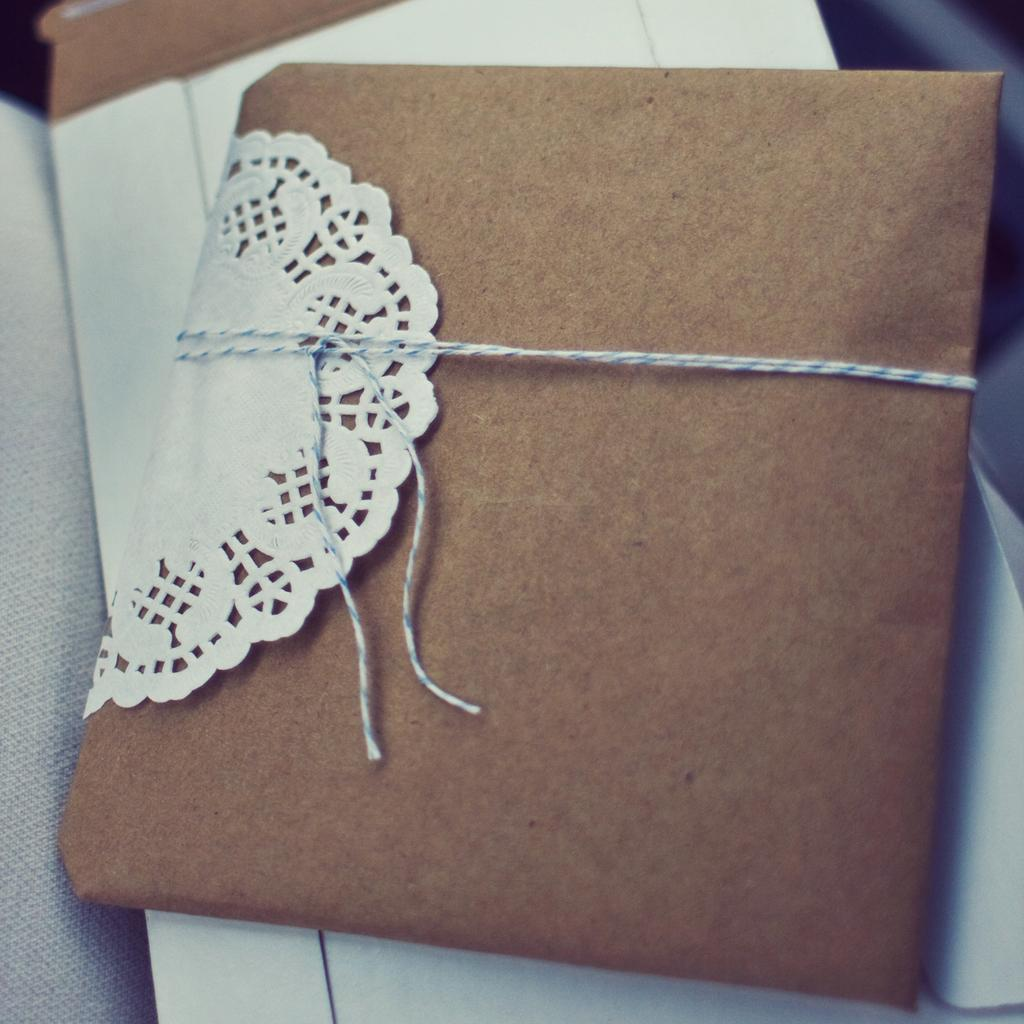What is the main object in the image? There is a wedding card in the image. Where is the wedding card placed? The wedding card is on a blanket. How is the wedding card secured or attached to the blanket? The wedding card is tied with a thread. What type of minister is present in the image? There is no minister present in the image; it only features a wedding card on a blanket. What kind of support apparatus can be seen holding up the wedding card? There is no support apparatus present in the image; the wedding card is tied with a thread. 